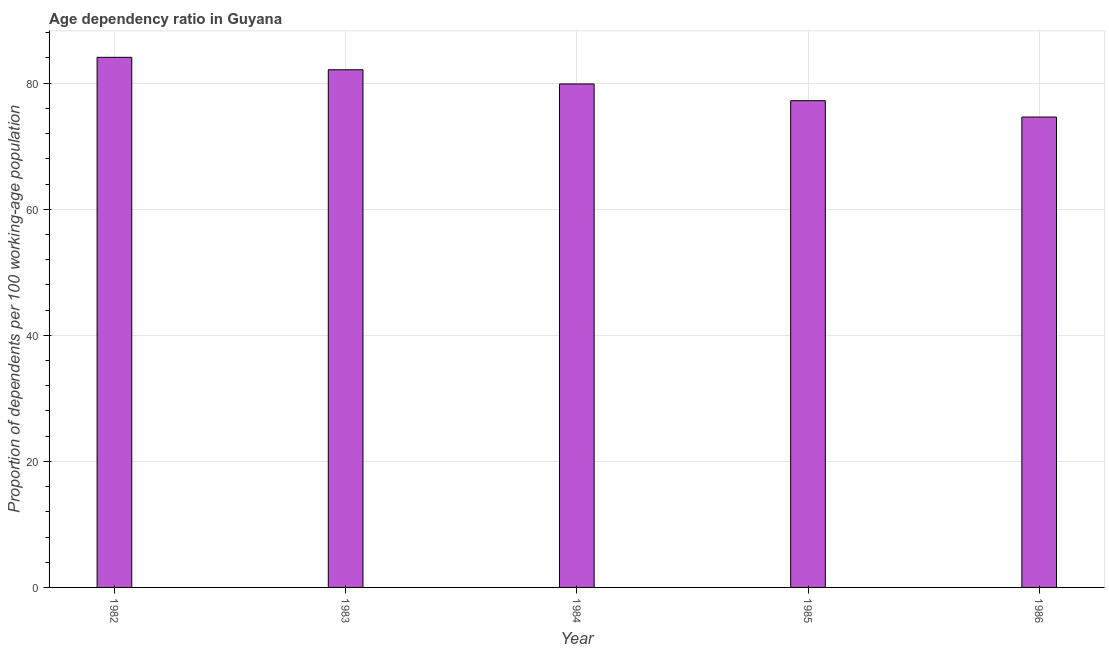Does the graph contain any zero values?
Your answer should be compact. No. What is the title of the graph?
Your answer should be very brief. Age dependency ratio in Guyana. What is the label or title of the Y-axis?
Give a very brief answer. Proportion of dependents per 100 working-age population. What is the age dependency ratio in 1985?
Your answer should be compact. 77.22. Across all years, what is the maximum age dependency ratio?
Your response must be concise. 84.1. Across all years, what is the minimum age dependency ratio?
Give a very brief answer. 74.63. In which year was the age dependency ratio maximum?
Keep it short and to the point. 1982. What is the sum of the age dependency ratio?
Your answer should be compact. 397.96. What is the difference between the age dependency ratio in 1985 and 1986?
Provide a succinct answer. 2.59. What is the average age dependency ratio per year?
Keep it short and to the point. 79.59. What is the median age dependency ratio?
Keep it short and to the point. 79.88. Do a majority of the years between 1986 and 1984 (inclusive) have age dependency ratio greater than 44 ?
Your response must be concise. Yes. What is the ratio of the age dependency ratio in 1984 to that in 1986?
Offer a very short reply. 1.07. Is the age dependency ratio in 1983 less than that in 1984?
Your response must be concise. No. What is the difference between the highest and the second highest age dependency ratio?
Provide a succinct answer. 1.97. Is the sum of the age dependency ratio in 1982 and 1986 greater than the maximum age dependency ratio across all years?
Offer a very short reply. Yes. What is the difference between the highest and the lowest age dependency ratio?
Offer a terse response. 9.47. How many bars are there?
Provide a succinct answer. 5. How many years are there in the graph?
Your answer should be compact. 5. What is the difference between two consecutive major ticks on the Y-axis?
Offer a terse response. 20. What is the Proportion of dependents per 100 working-age population of 1982?
Your response must be concise. 84.1. What is the Proportion of dependents per 100 working-age population of 1983?
Give a very brief answer. 82.13. What is the Proportion of dependents per 100 working-age population of 1984?
Provide a succinct answer. 79.88. What is the Proportion of dependents per 100 working-age population of 1985?
Your response must be concise. 77.22. What is the Proportion of dependents per 100 working-age population in 1986?
Your response must be concise. 74.63. What is the difference between the Proportion of dependents per 100 working-age population in 1982 and 1983?
Your answer should be very brief. 1.97. What is the difference between the Proportion of dependents per 100 working-age population in 1982 and 1984?
Offer a terse response. 4.22. What is the difference between the Proportion of dependents per 100 working-age population in 1982 and 1985?
Your answer should be very brief. 6.88. What is the difference between the Proportion of dependents per 100 working-age population in 1982 and 1986?
Your answer should be very brief. 9.47. What is the difference between the Proportion of dependents per 100 working-age population in 1983 and 1984?
Provide a succinct answer. 2.26. What is the difference between the Proportion of dependents per 100 working-age population in 1983 and 1985?
Ensure brevity in your answer.  4.91. What is the difference between the Proportion of dependents per 100 working-age population in 1983 and 1986?
Provide a succinct answer. 7.51. What is the difference between the Proportion of dependents per 100 working-age population in 1984 and 1985?
Your response must be concise. 2.66. What is the difference between the Proportion of dependents per 100 working-age population in 1984 and 1986?
Make the answer very short. 5.25. What is the difference between the Proportion of dependents per 100 working-age population in 1985 and 1986?
Your answer should be very brief. 2.59. What is the ratio of the Proportion of dependents per 100 working-age population in 1982 to that in 1983?
Offer a terse response. 1.02. What is the ratio of the Proportion of dependents per 100 working-age population in 1982 to that in 1984?
Ensure brevity in your answer.  1.05. What is the ratio of the Proportion of dependents per 100 working-age population in 1982 to that in 1985?
Ensure brevity in your answer.  1.09. What is the ratio of the Proportion of dependents per 100 working-age population in 1982 to that in 1986?
Give a very brief answer. 1.13. What is the ratio of the Proportion of dependents per 100 working-age population in 1983 to that in 1984?
Give a very brief answer. 1.03. What is the ratio of the Proportion of dependents per 100 working-age population in 1983 to that in 1985?
Give a very brief answer. 1.06. What is the ratio of the Proportion of dependents per 100 working-age population in 1983 to that in 1986?
Offer a terse response. 1.1. What is the ratio of the Proportion of dependents per 100 working-age population in 1984 to that in 1985?
Offer a very short reply. 1.03. What is the ratio of the Proportion of dependents per 100 working-age population in 1984 to that in 1986?
Keep it short and to the point. 1.07. What is the ratio of the Proportion of dependents per 100 working-age population in 1985 to that in 1986?
Your response must be concise. 1.03. 